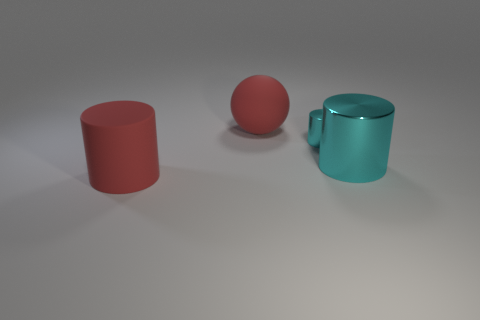Subtract all shiny cylinders. How many cylinders are left? 1 Add 4 cylinders. How many objects exist? 8 Subtract all red cylinders. How many cylinders are left? 2 Subtract all spheres. How many objects are left? 3 Subtract all brown cylinders. Subtract all brown balls. How many cylinders are left? 3 Subtract all gray blocks. How many gray spheres are left? 0 Subtract all large shiny cylinders. Subtract all large rubber spheres. How many objects are left? 2 Add 1 big red objects. How many big red objects are left? 3 Add 3 large matte balls. How many large matte balls exist? 4 Subtract 0 purple cylinders. How many objects are left? 4 